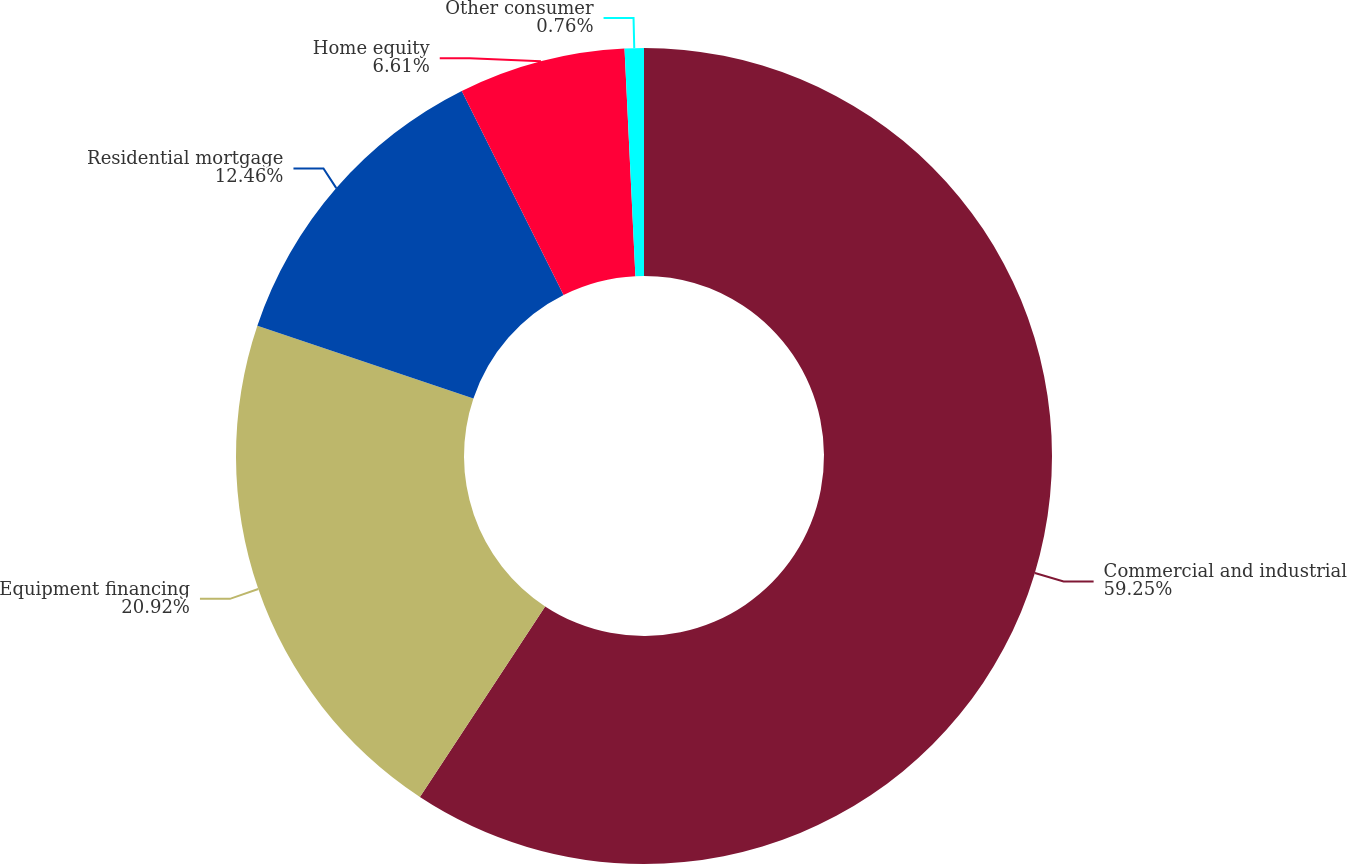Convert chart to OTSL. <chart><loc_0><loc_0><loc_500><loc_500><pie_chart><fcel>Commercial and industrial<fcel>Equipment financing<fcel>Residential mortgage<fcel>Home equity<fcel>Other consumer<nl><fcel>59.26%<fcel>20.92%<fcel>12.46%<fcel>6.61%<fcel>0.76%<nl></chart> 